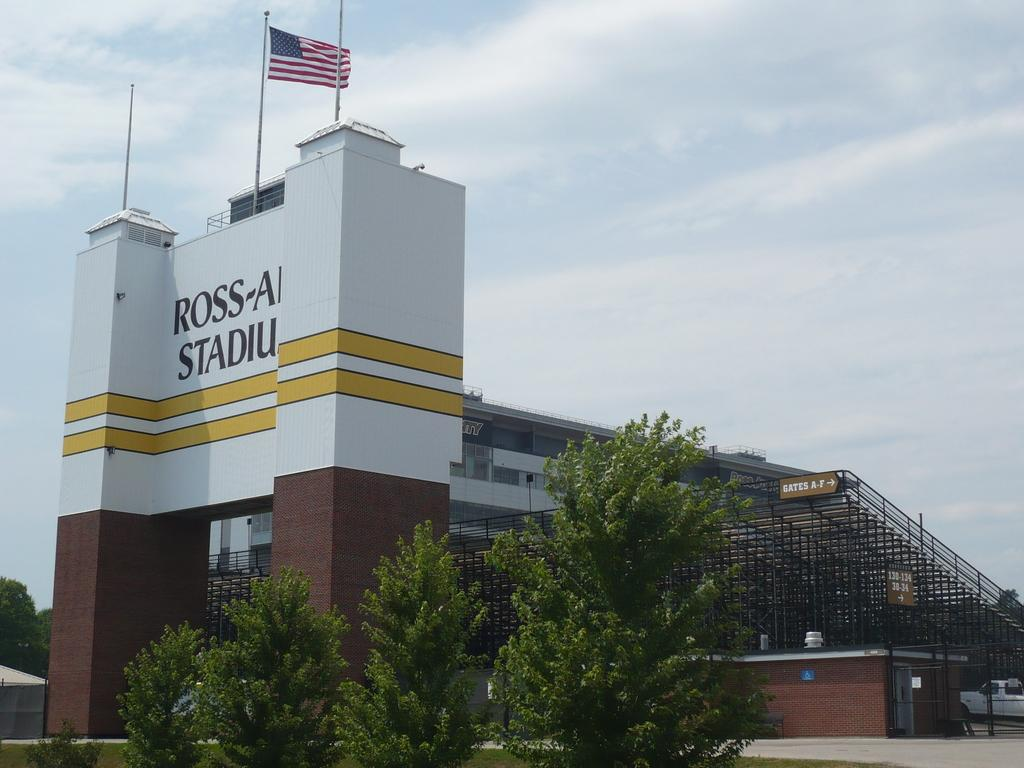Provide a one-sentence caption for the provided image. Gates A-F are to the right of the main entrance to a stadium. 